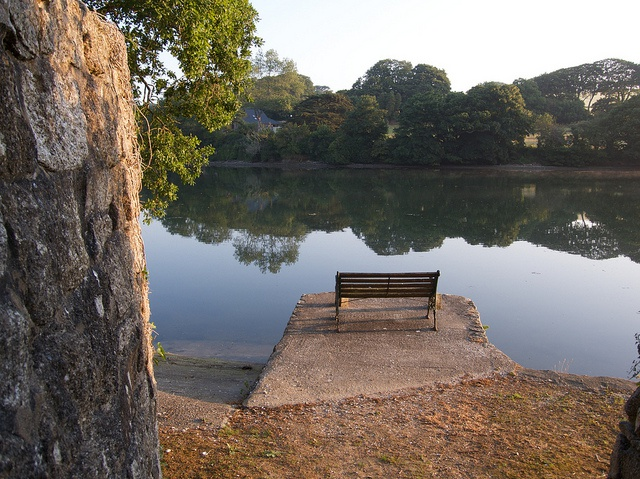Describe the objects in this image and their specific colors. I can see a bench in black, gray, and darkgray tones in this image. 